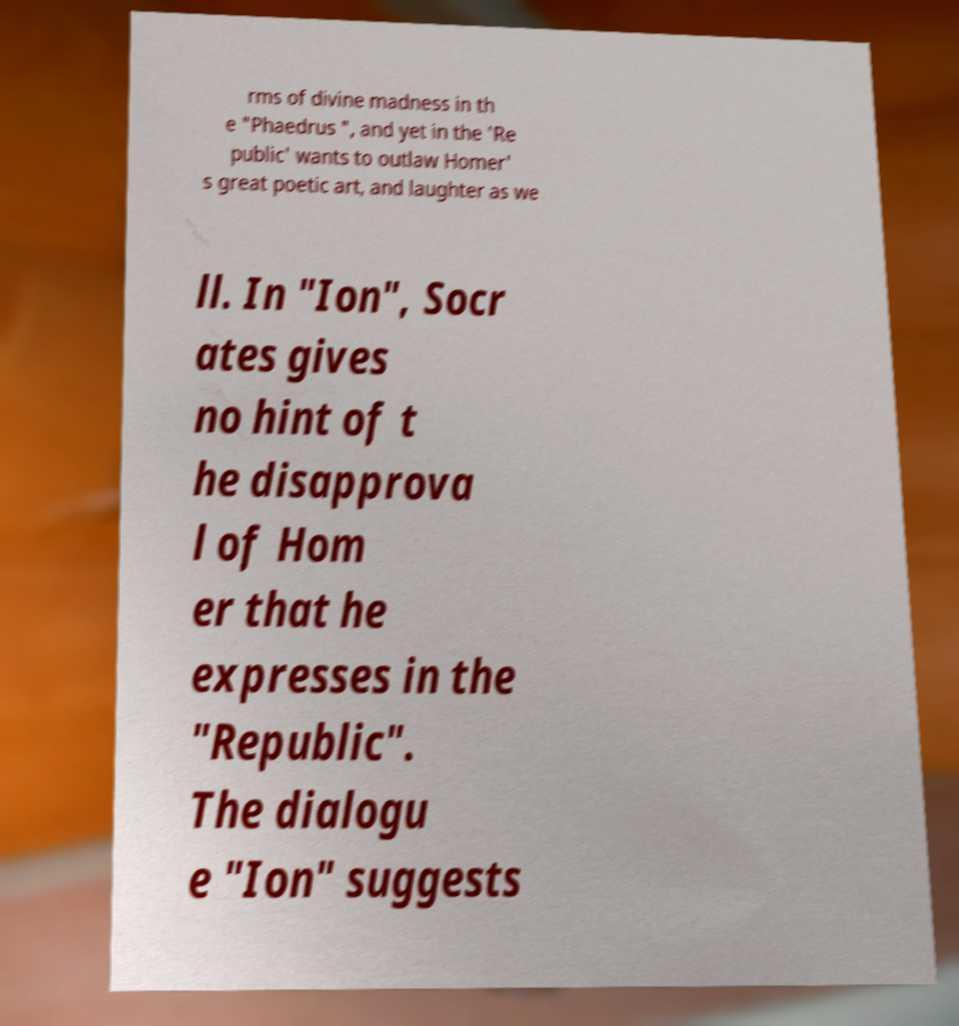Please read and relay the text visible in this image. What does it say? rms of divine madness in th e "Phaedrus ", and yet in the 'Re public' wants to outlaw Homer' s great poetic art, and laughter as we ll. In "Ion", Socr ates gives no hint of t he disapprova l of Hom er that he expresses in the "Republic". The dialogu e "Ion" suggests 